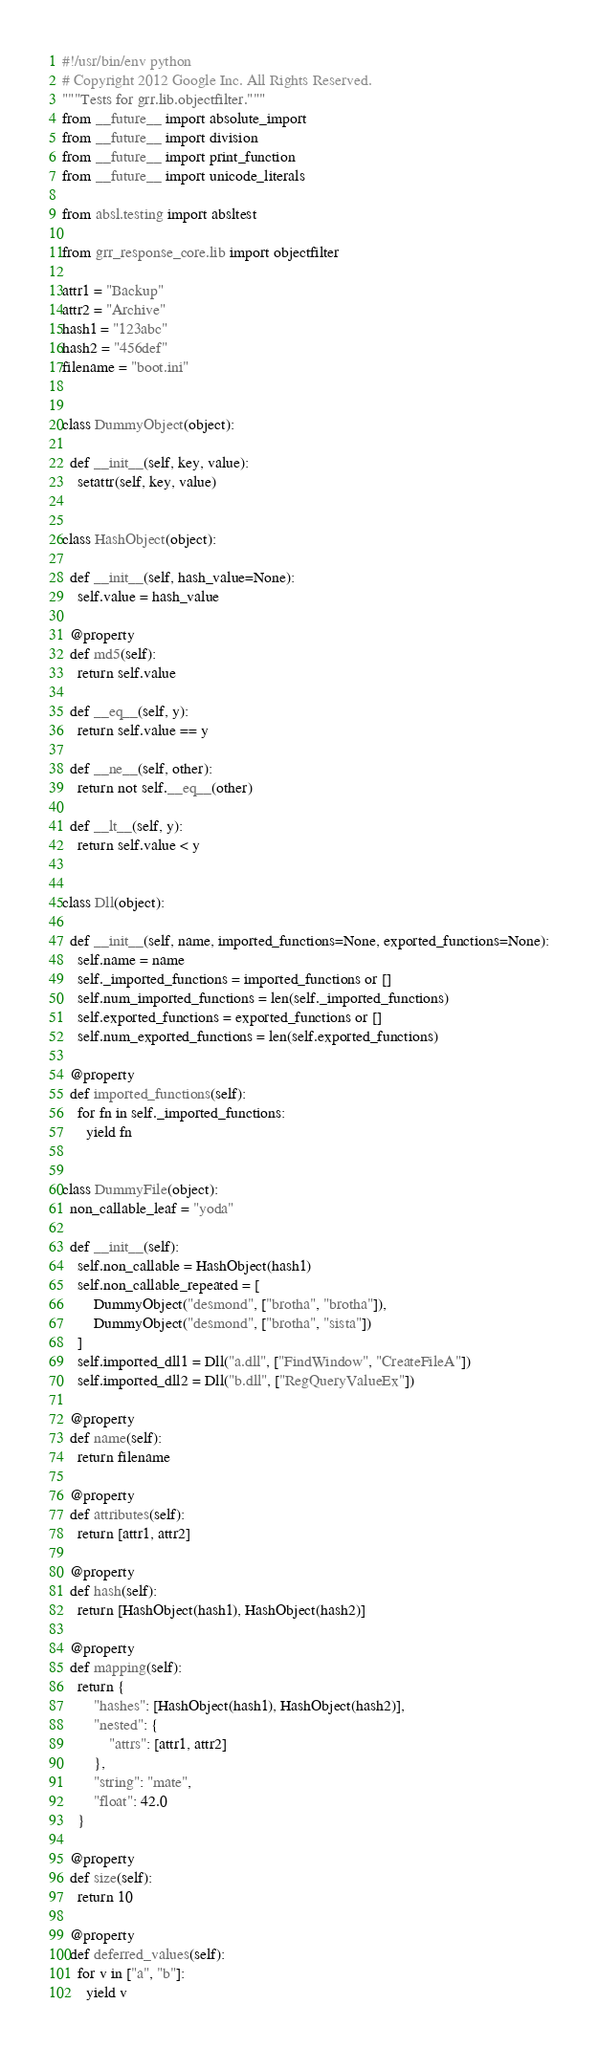<code> <loc_0><loc_0><loc_500><loc_500><_Python_>#!/usr/bin/env python
# Copyright 2012 Google Inc. All Rights Reserved.
"""Tests for grr.lib.objectfilter."""
from __future__ import absolute_import
from __future__ import division
from __future__ import print_function
from __future__ import unicode_literals

from absl.testing import absltest

from grr_response_core.lib import objectfilter

attr1 = "Backup"
attr2 = "Archive"
hash1 = "123abc"
hash2 = "456def"
filename = "boot.ini"


class DummyObject(object):

  def __init__(self, key, value):
    setattr(self, key, value)


class HashObject(object):

  def __init__(self, hash_value=None):
    self.value = hash_value

  @property
  def md5(self):
    return self.value

  def __eq__(self, y):
    return self.value == y

  def __ne__(self, other):
    return not self.__eq__(other)

  def __lt__(self, y):
    return self.value < y


class Dll(object):

  def __init__(self, name, imported_functions=None, exported_functions=None):
    self.name = name
    self._imported_functions = imported_functions or []
    self.num_imported_functions = len(self._imported_functions)
    self.exported_functions = exported_functions or []
    self.num_exported_functions = len(self.exported_functions)

  @property
  def imported_functions(self):
    for fn in self._imported_functions:
      yield fn


class DummyFile(object):
  non_callable_leaf = "yoda"

  def __init__(self):
    self.non_callable = HashObject(hash1)
    self.non_callable_repeated = [
        DummyObject("desmond", ["brotha", "brotha"]),
        DummyObject("desmond", ["brotha", "sista"])
    ]
    self.imported_dll1 = Dll("a.dll", ["FindWindow", "CreateFileA"])
    self.imported_dll2 = Dll("b.dll", ["RegQueryValueEx"])

  @property
  def name(self):
    return filename

  @property
  def attributes(self):
    return [attr1, attr2]

  @property
  def hash(self):
    return [HashObject(hash1), HashObject(hash2)]

  @property
  def mapping(self):
    return {
        "hashes": [HashObject(hash1), HashObject(hash2)],
        "nested": {
            "attrs": [attr1, attr2]
        },
        "string": "mate",
        "float": 42.0
    }

  @property
  def size(self):
    return 10

  @property
  def deferred_values(self):
    for v in ["a", "b"]:
      yield v
</code> 